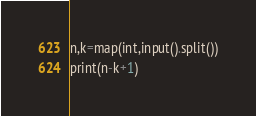Convert code to text. <code><loc_0><loc_0><loc_500><loc_500><_Python_>n,k=map(int,input().split())
print(n-k+1)</code> 